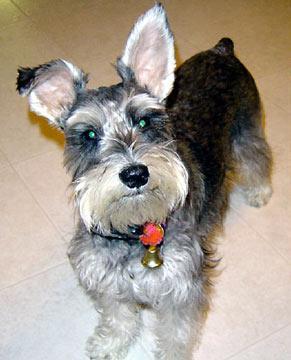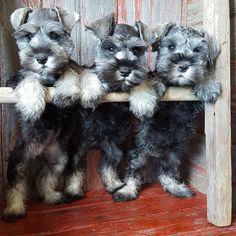The first image is the image on the left, the second image is the image on the right. Examine the images to the left and right. Is the description "There are exactly four dogs." accurate? Answer yes or no. Yes. The first image is the image on the left, the second image is the image on the right. Examine the images to the left and right. Is the description "there is three dogs in the right side image" accurate? Answer yes or no. Yes. 